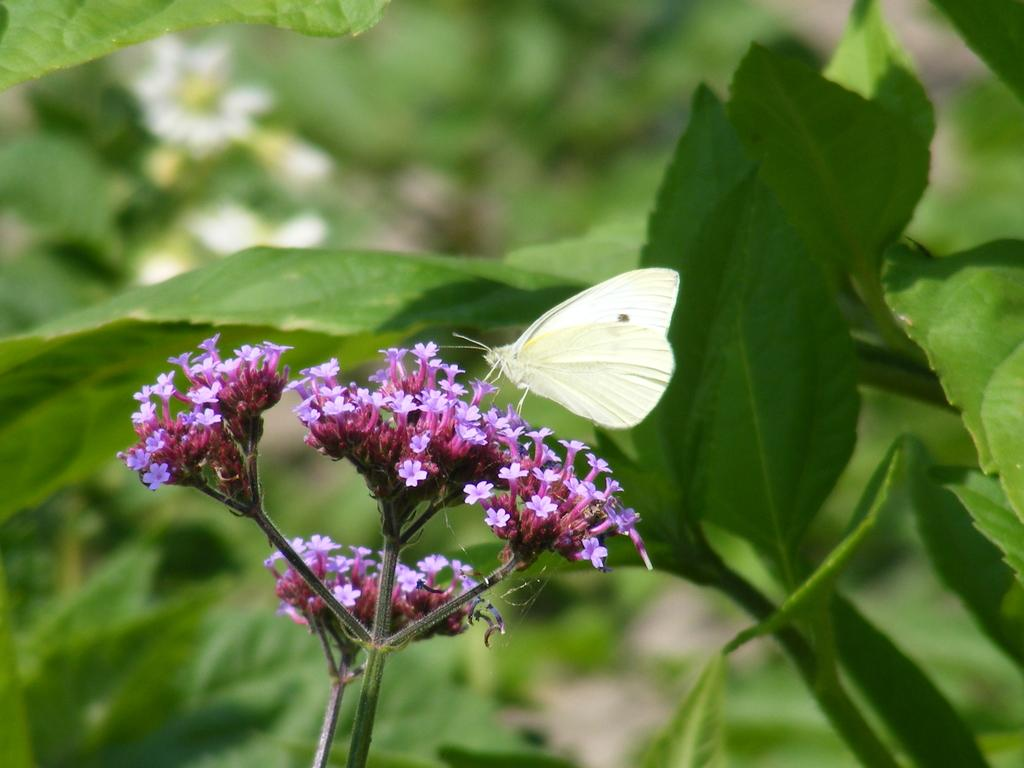What is the main subject of the image? The main subject of the image is bunches of flowers. What can be observed about the flowers' structure? The flowers have stems. Is there any other living creature present in the image? Yes, there is a butterfly on the flowers. What color are the leaves in the image? The leaves in the image are green. Who is the manager of the flowers in the image? There is no manager present in the image, as flowers do not have managers. Can you tell me how many berries are on the flowers in the image? There are no berries present on the flowers in the image; it features bunches of flowers with stems and a butterfly. 